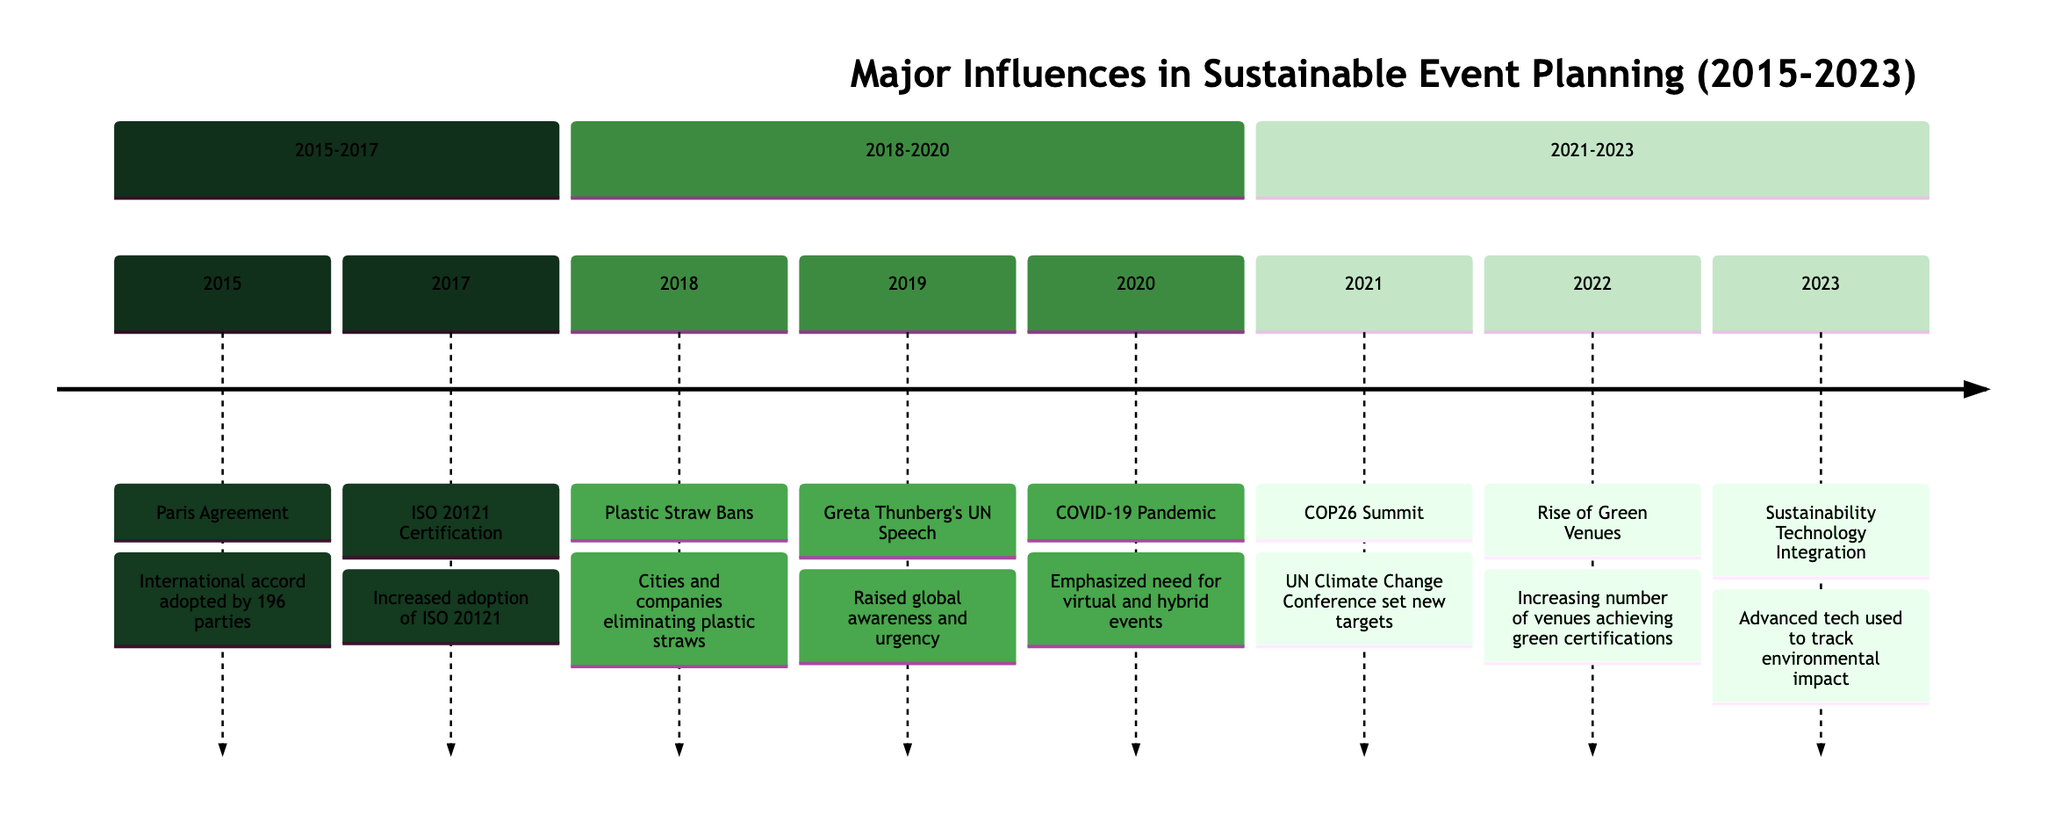What major agreement was reached in 2015? The timeline indicates that the Paris Agreement was adopted in 2015. This was a significant international accord related to climate change and sustainability.
Answer: Paris Agreement How many major events are listed for the year 2021? In the timeline, there is one event listed for the year 2021, which is the COP26 Summit.
Answer: 1 Which event in 2018 focused on single-use plastics? The timeline includes the Plastic Straw Bans event in 2018, which specifically addressed the issue of single-use plastics.
Answer: Plastic Straw Bans What significant global awareness event occurred in 2019? According to the timeline, Greta Thunberg's speech at the UN Climate Action Summit in 2019 raised global awareness regarding climate change and sustainability.
Answer: Greta Thunberg's UN Speech Which year marked the beginning of the integration of sustainability technologies? The timeline shows that the integration of Sustainability Technology occurred in 2023, marking a significant advancement in tracking environmental impact.
Answer: 2023 Which event's impact is primarily associated with the COVID-19 pandemic? The timeline states that the COVID-19 Pandemic in 2020 emphasized the necessity for virtual and hybrid events, which was a direct response to the pandemic's restrictions.
Answer: COVID-19 Pandemic What trend was noted in the event industry in 2022? The timeline highlights the rise of Green Venues in 2022, indicating a trend where more venues achieved green certifications and implemented sustainable practices.
Answer: Rise of Green Venues Which two events occurred closest together in time? Looking closely at the timeline, the events are organized chronologically. The Plastic Straw Bans (2018) and Greta Thunberg's UN Speech (2019) are the two events that occurred consecutively with one year apart.
Answer: Plastic Straw Bans and Greta Thunberg's UN Speech What standard was increasingly adopted by event planners in 2017? The timeline specifies that the ISO 20121 Certification was adopted more widely in 2017, significantly influencing event planning practices towards sustainability.
Answer: ISO 20121 Certification 